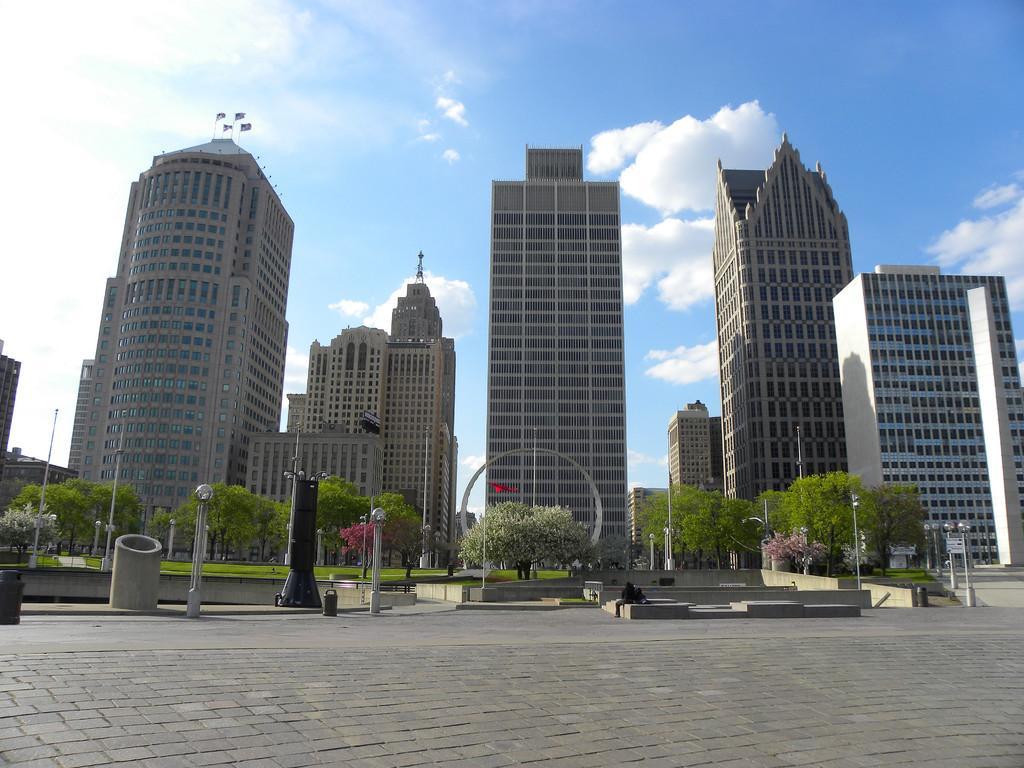How would you summarize this image in a sentence or two? In this image the foreground there are some pole like objects, and there are pipes. In the background there are buildings, trees, poles, grass and at the bottom there is walkway and there are some boards and objects. And at the top of the image there is sky, and on the left side of the image there are poles and flags on the building. 